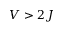<formula> <loc_0><loc_0><loc_500><loc_500>V > 2 J</formula> 